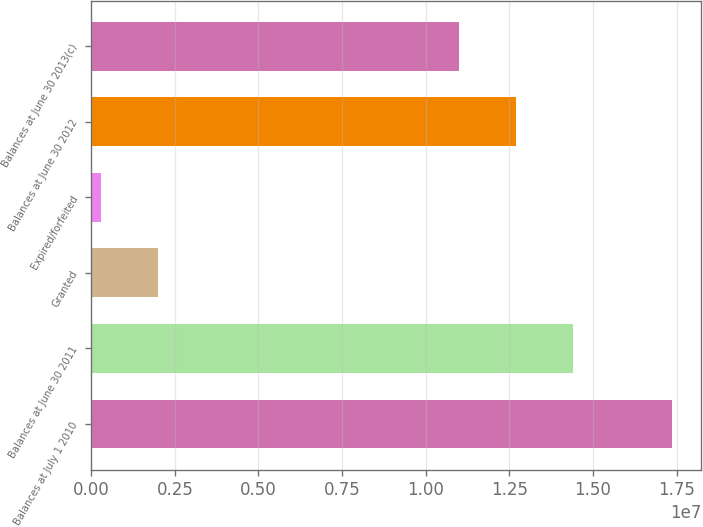Convert chart to OTSL. <chart><loc_0><loc_0><loc_500><loc_500><bar_chart><fcel>Balances at July 1 2010<fcel>Balances at June 30 2011<fcel>Granted<fcel>Expired/forfeited<fcel>Balances at June 30 2012<fcel>Balances at June 30 2013(c)<nl><fcel>1.73692e+07<fcel>1.43995e+07<fcel>2.00617e+06<fcel>299163<fcel>1.26925e+07<fcel>1.09855e+07<nl></chart> 